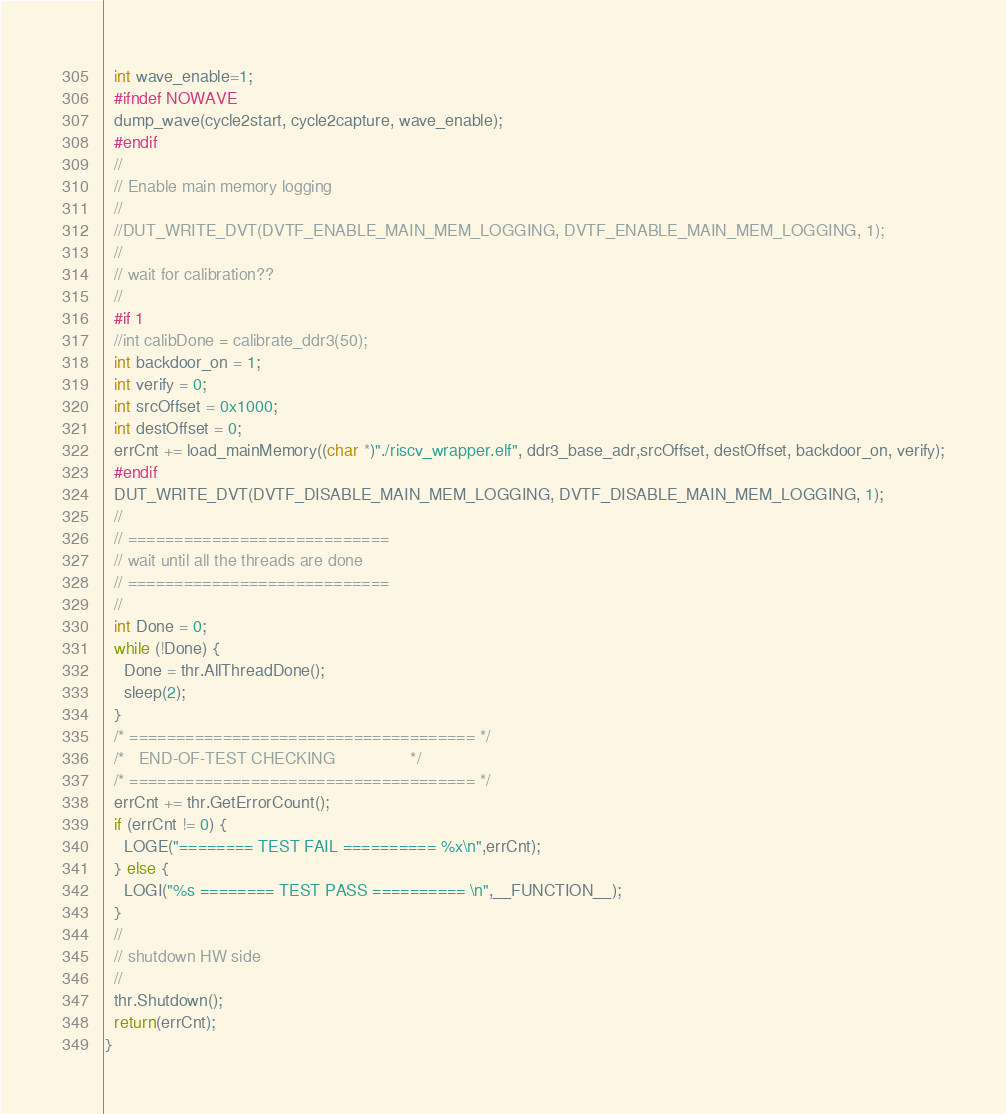Convert code to text. <code><loc_0><loc_0><loc_500><loc_500><_C++_>  int wave_enable=1;
  #ifndef NOWAVE
  dump_wave(cycle2start, cycle2capture, wave_enable);
  #endif
  //
  // Enable main memory logging
  //
  //DUT_WRITE_DVT(DVTF_ENABLE_MAIN_MEM_LOGGING, DVTF_ENABLE_MAIN_MEM_LOGGING, 1);
  //
  // wait for calibration??
  //
  #if 1
  //int calibDone = calibrate_ddr3(50);
  int backdoor_on = 1;
  int verify = 0;
  int srcOffset = 0x1000;
  int destOffset = 0;
  errCnt += load_mainMemory((char *)"./riscv_wrapper.elf", ddr3_base_adr,srcOffset, destOffset, backdoor_on, verify);
  #endif
  DUT_WRITE_DVT(DVTF_DISABLE_MAIN_MEM_LOGGING, DVTF_DISABLE_MAIN_MEM_LOGGING, 1);  
  //
  // ============================  
  // wait until all the threads are done
  // ============================  
  //
  int Done = 0;
  while (!Done) {
    Done = thr.AllThreadDone();
    sleep(2);
  }
  /* ===================================== */
  /*   END-OF-TEST CHECKING                */
  /* ===================================== */
  errCnt += thr.GetErrorCount();
  if (errCnt != 0) {
    LOGE("======== TEST FAIL ========== %x\n",errCnt);
  } else {
    LOGI("%s ======== TEST PASS ========== \n",__FUNCTION__);
  }
  //
  // shutdown HW side
  //
  thr.Shutdown();
  return(errCnt);
}
</code> 